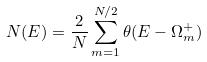Convert formula to latex. <formula><loc_0><loc_0><loc_500><loc_500>N ( E ) = \frac { 2 } { N } \sum _ { m = 1 } ^ { N / 2 } \theta ( E - \Omega _ { m } ^ { + } )</formula> 